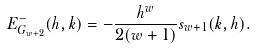<formula> <loc_0><loc_0><loc_500><loc_500>E _ { G _ { w + 2 } } ^ { - } ( h , k ) = - \frac { h ^ { w } } { 2 ( w + 1 ) } s _ { w + 1 } ( k , h ) .</formula> 